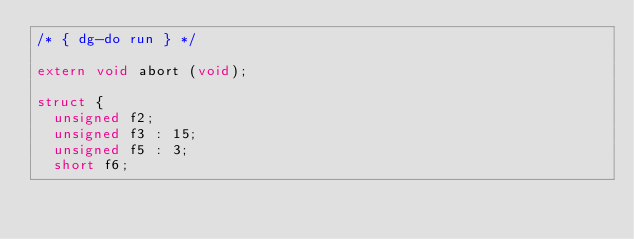Convert code to text. <code><loc_0><loc_0><loc_500><loc_500><_C_>/* { dg-do run } */

extern void abort (void);

struct {
  unsigned f2;
  unsigned f3 : 15;
  unsigned f5 : 3;
  short f6;</code> 